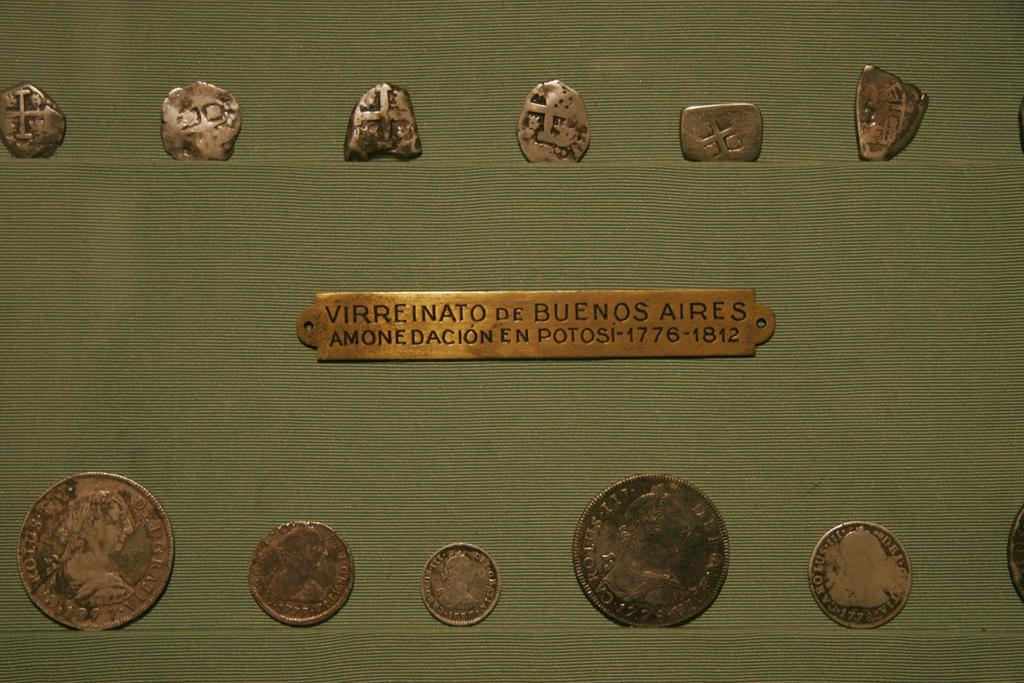What dates are shown on the piece in the center?
Offer a terse response. 1776-1812. What capital city is written there?
Your response must be concise. Buenos aires. 